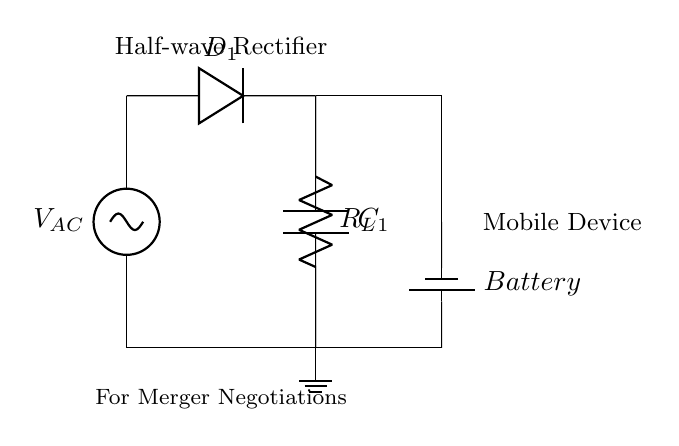What type of rectifier is shown in the circuit? The circuit is labeled as a "Half-wave Rectifier," which indicates the type used to convert AC to DC using only one half of the input waveform.
Answer: Half-wave Rectifier What component is used to smooth the output voltage? The circuit includes a smoothing capacitor labeled as "C1," which is used to reduce voltage fluctuations after rectification, thus smoothing the output voltage.
Answer: C1 What does the symbol "D" represent in the circuit? The symbol "D" in the diagram represents a diode, specifically labeled as "D1," which allows current to flow in one direction, essential for rectification.
Answer: D1 How many output connections does the circuit have? The circuit has two output connections: one from the load resistor and one from the smoothing capacitor leading to the battery, making a total of two.
Answer: Two Why is a smoothing capacitor important in this circuit? The smoothing capacitor "C1" is crucial for maintaining a steady voltage output, as it charges during the peaks of the rectified voltage and discharges during the troughs, thus minimizing ripple.
Answer: Steady voltage output What is the function of the load resistor in the circuit? The load resistor "R_L" is connected to the output and simulates the consumption of power by the mobile device, allowing for practical assessment of the charging circuit's performance.
Answer: Simulate power consumption Which component is responsible for charging the battery? The battery symbol connected to the circuit indicates that the output charge from the rectifier circuit is directed to the battery for storage, facilitated by the output connections.
Answer: Battery 